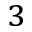<formula> <loc_0><loc_0><loc_500><loc_500>^ { 3 }</formula> 